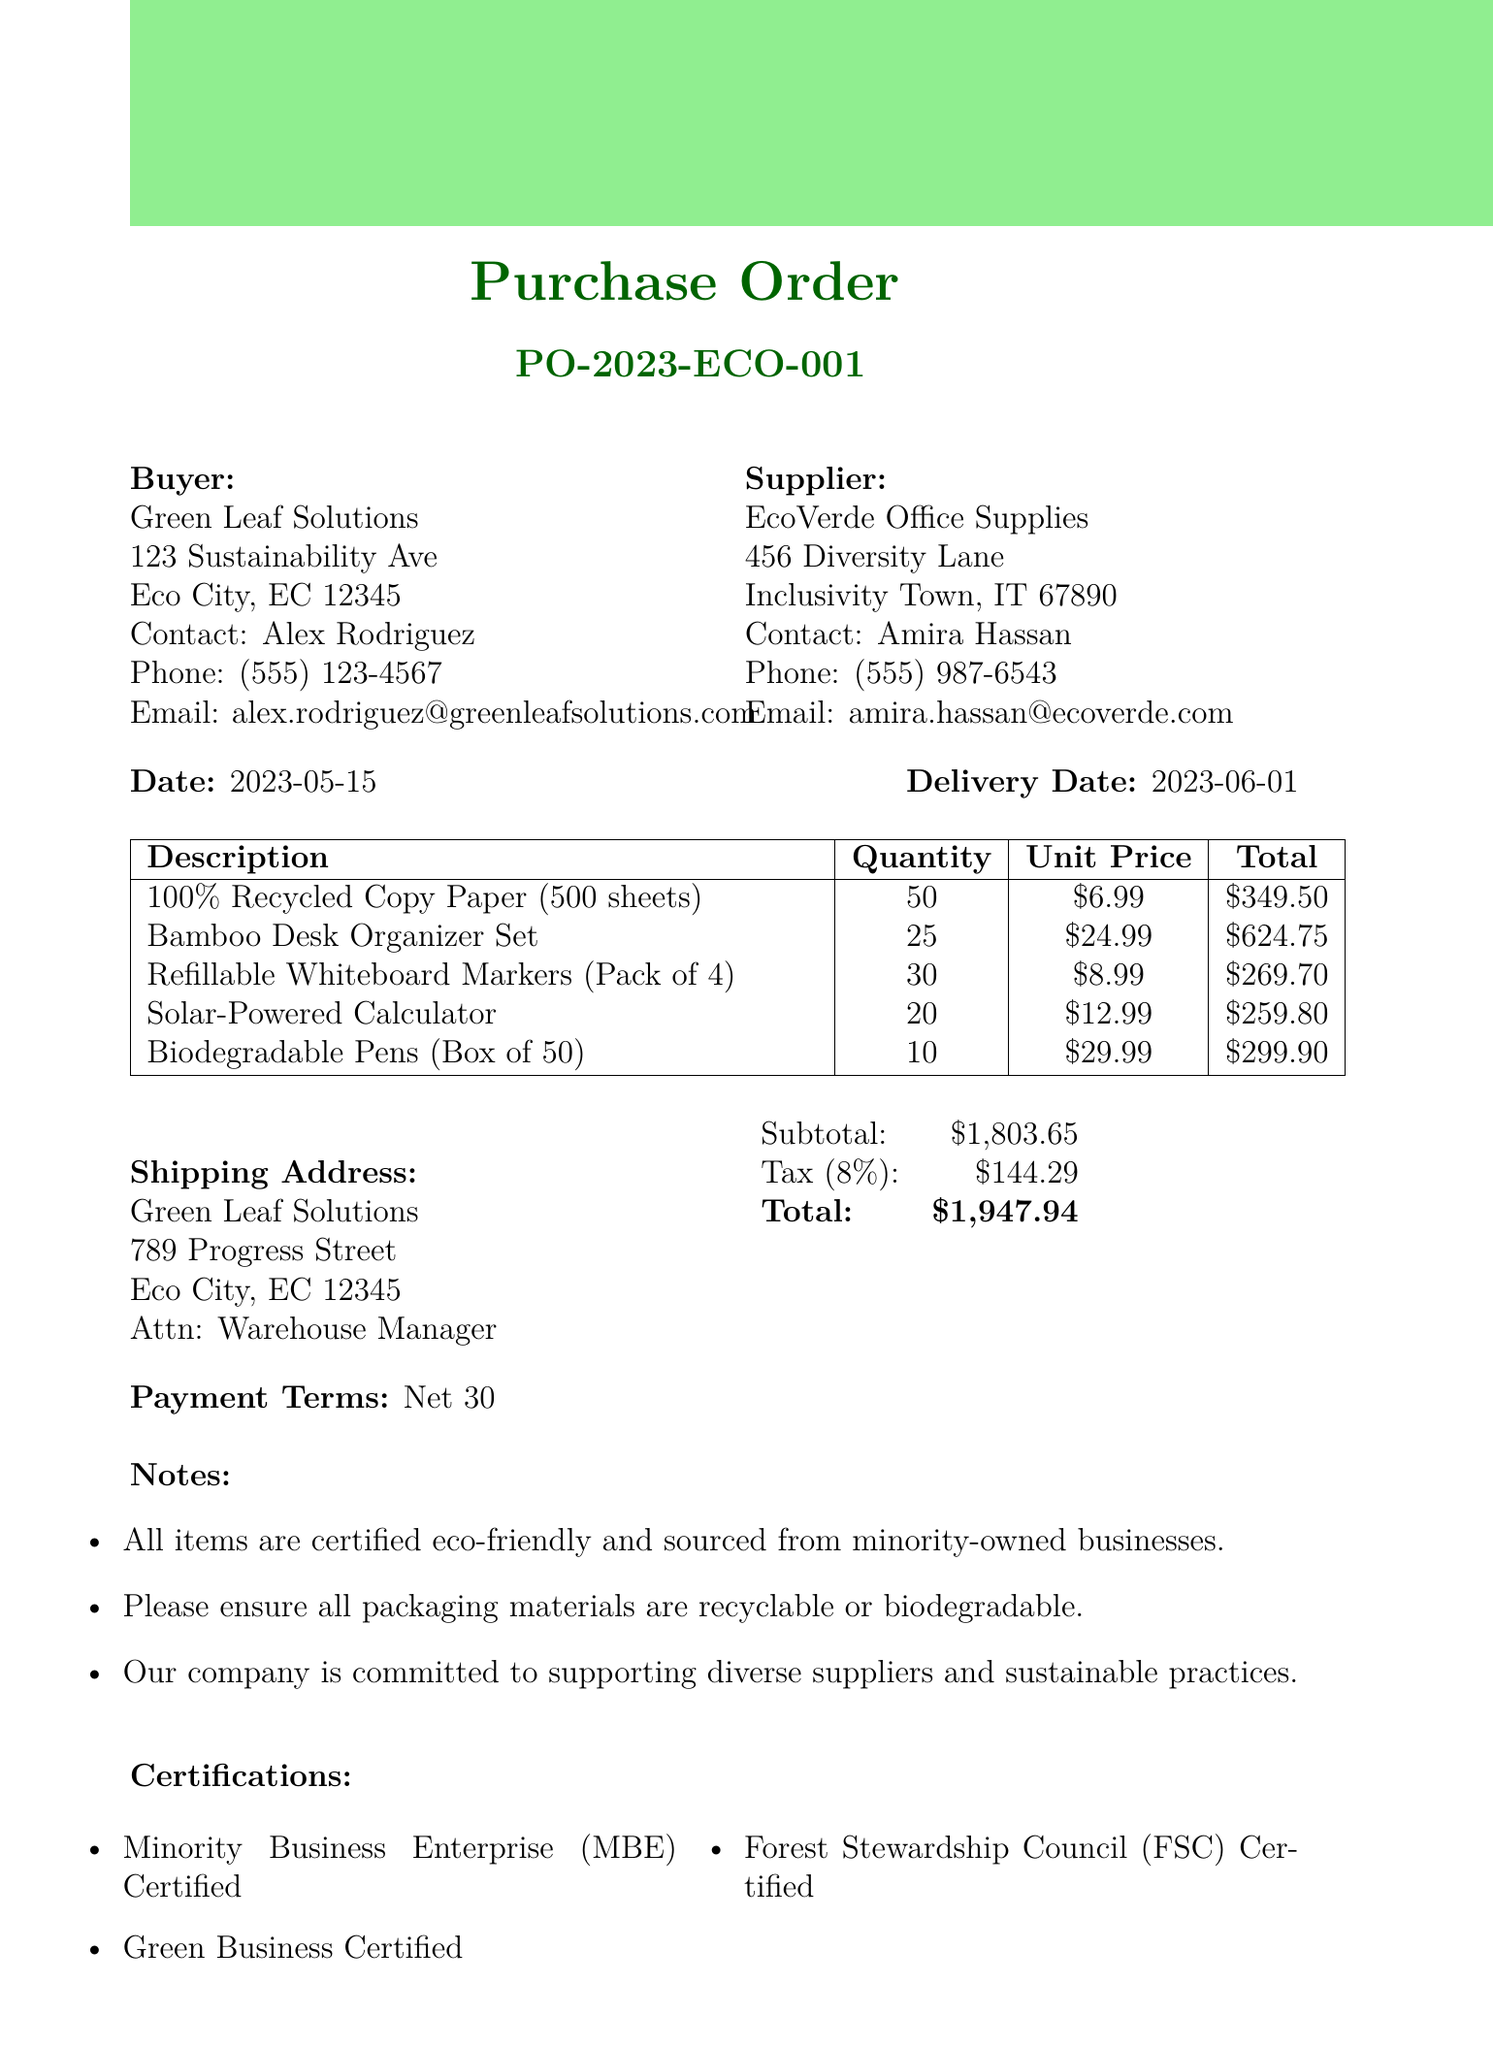What is the order number? The order number is specified at the beginning of the document as PO-2023-ECO-001.
Answer: PO-2023-ECO-001 Who is the buyer's contact person? The buyer's contact person is listed under the buyer's details section.
Answer: Alex Rodriguez What is the total amount for the order? The total amount is calculated from the subtotal and tax information provided in the document.
Answer: $1947.94 What is the delivery date? The delivery date is mentioned alongside the date of the document.
Answer: 2023-06-01 How many units of biodegradable pens are ordered? The quantity of biodegradable pens is detailed in the items section of the document.
Answer: 10 What is the tax rate applied to this order? The tax rate for this order is explicitly stated in the payment details section.
Answer: 8% Name one certification of the supplier. The certifications for the supplier are listed in the certifications section of the document.
Answer: Minority Business Enterprise (MBE) Certified What is the shipping address? The shipping address is provided in a dedicated section of the document.
Answer: 789 Progress Street, Eco City, EC 12345 What is the payment term? The payment terms are clearly specified in the payment details section of the document.
Answer: Net 30 